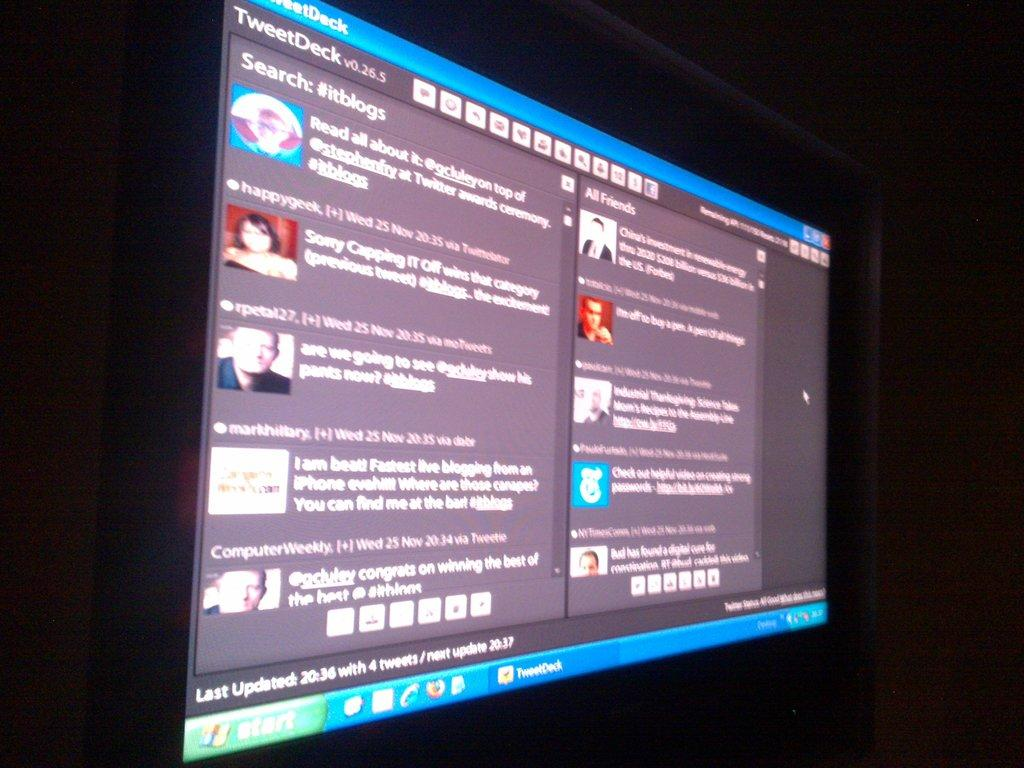<image>
Give a short and clear explanation of the subsequent image. A monitor shows the Tweetdeck program on the display. 